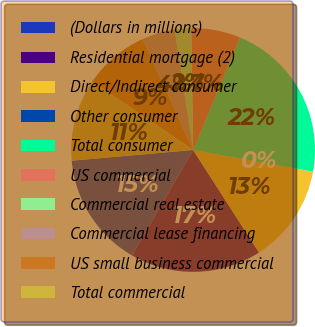Convert chart. <chart><loc_0><loc_0><loc_500><loc_500><pie_chart><fcel>(Dollars in millions)<fcel>Residential mortgage (2)<fcel>Direct/Indirect consumer<fcel>Other consumer<fcel>Total consumer<fcel>US commercial<fcel>Commercial real estate<fcel>Commercial lease financing<fcel>US small business commercial<fcel>Total commercial<nl><fcel>15.25%<fcel>17.43%<fcel>13.07%<fcel>0.0%<fcel>21.55%<fcel>6.54%<fcel>2.18%<fcel>4.36%<fcel>8.72%<fcel>10.9%<nl></chart> 